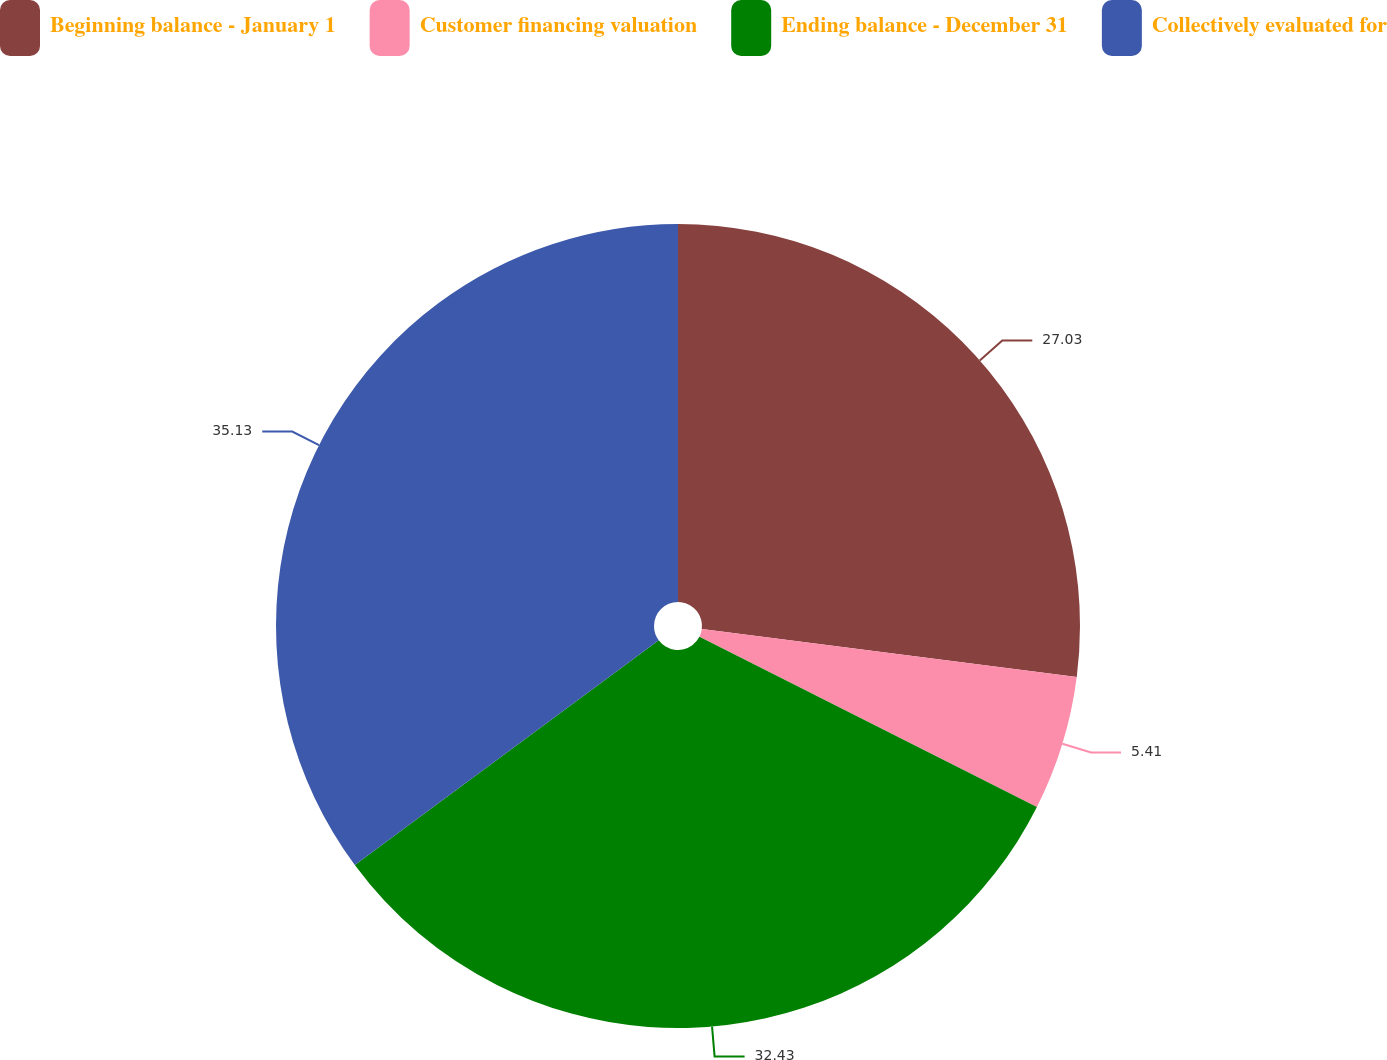<chart> <loc_0><loc_0><loc_500><loc_500><pie_chart><fcel>Beginning balance - January 1<fcel>Customer financing valuation<fcel>Ending balance - December 31<fcel>Collectively evaluated for<nl><fcel>27.03%<fcel>5.41%<fcel>32.43%<fcel>35.14%<nl></chart> 